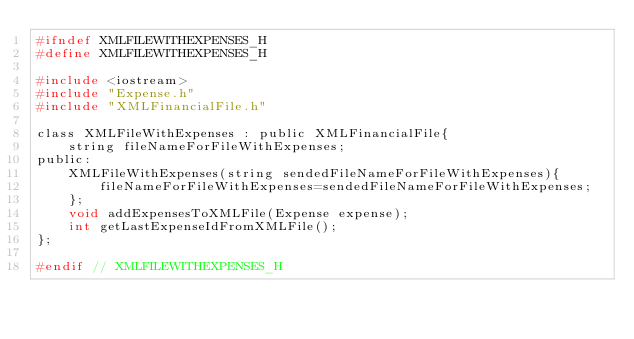<code> <loc_0><loc_0><loc_500><loc_500><_C_>#ifndef XMLFILEWITHEXPENSES_H
#define XMLFILEWITHEXPENSES_H

#include <iostream>
#include "Expense.h"
#include "XMLFinancialFile.h"

class XMLFileWithExpenses : public XMLFinancialFile{
    string fileNameForFileWithExpenses;
public:
    XMLFileWithExpenses(string sendedFileNameForFileWithExpenses){
        fileNameForFileWithExpenses=sendedFileNameForFileWithExpenses;
    };
    void addExpensesToXMLFile(Expense expense);
    int getLastExpenseIdFromXMLFile();
};

#endif // XMLFILEWITHEXPENSES_H
</code> 